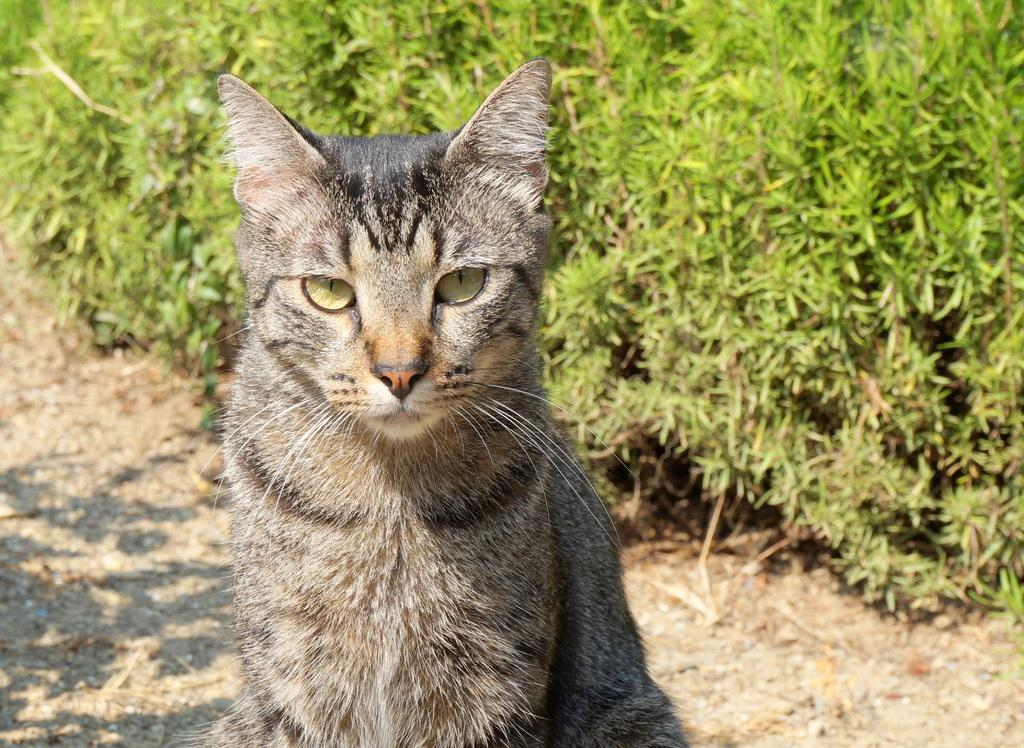What type of animal is present in the image? There is a cat in the image. What else can be seen in the image besides the cat? There are many plants in the image. What type of scarecrow is present in the image? There is no scarecrow present in the image; it only features a cat and plants. What is the cat thinking in the image? We cannot determine what the cat is thinking in the image, as thoughts are not visible. 